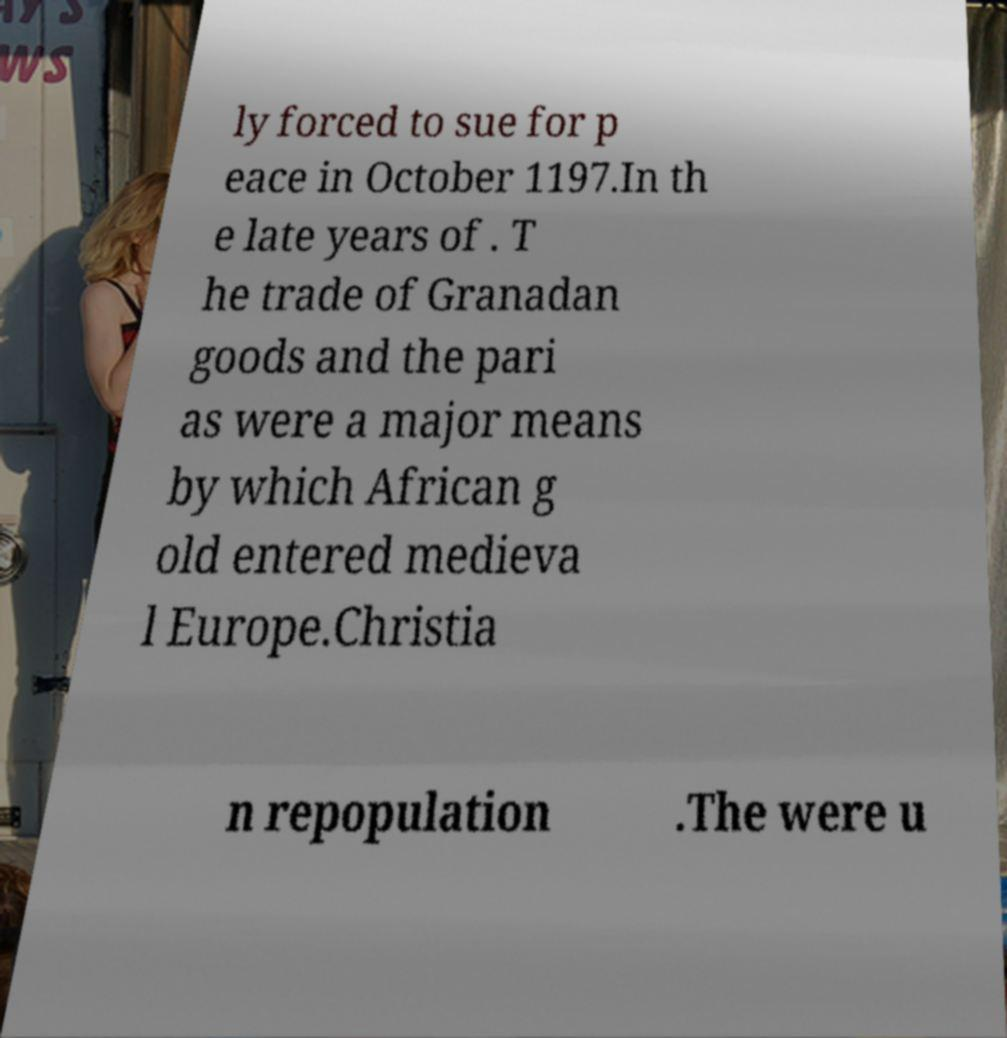Please read and relay the text visible in this image. What does it say? ly forced to sue for p eace in October 1197.In th e late years of . T he trade of Granadan goods and the pari as were a major means by which African g old entered medieva l Europe.Christia n repopulation .The were u 